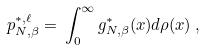<formula> <loc_0><loc_0><loc_500><loc_500>p _ { N , \beta } ^ { * , \ell } = \, \int _ { 0 } ^ { \infty } g _ { N , \beta } ^ { * } ( x ) d \rho ( x ) \, ,</formula> 